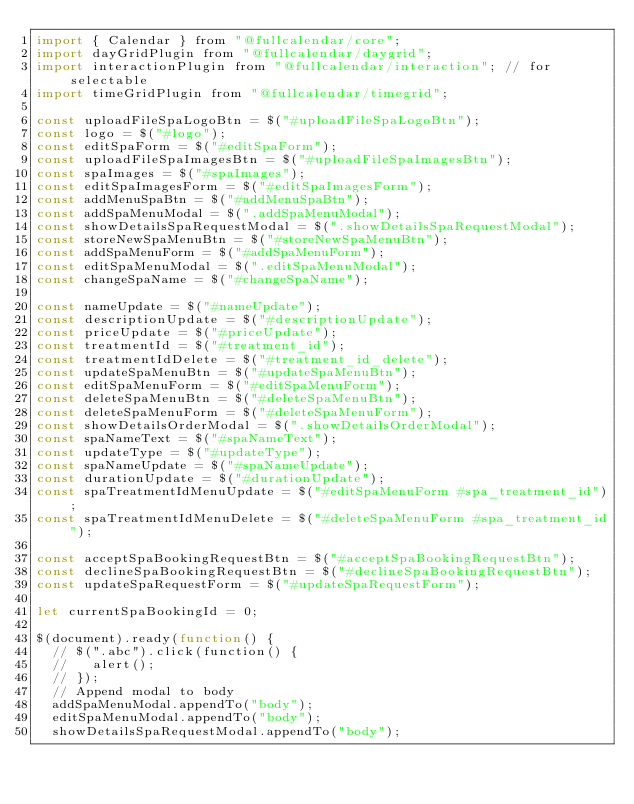Convert code to text. <code><loc_0><loc_0><loc_500><loc_500><_JavaScript_>import { Calendar } from "@fullcalendar/core";
import dayGridPlugin from "@fullcalendar/daygrid";
import interactionPlugin from "@fullcalendar/interaction"; // for selectable
import timeGridPlugin from "@fullcalendar/timegrid";

const uploadFileSpaLogoBtn = $("#uploadFileSpaLogoBtn");
const logo = $("#logo");
const editSpaForm = $("#editSpaForm");
const uploadFileSpaImagesBtn = $("#uploadFileSpaImagesBtn");
const spaImages = $("#spaImages");
const editSpaImagesForm = $("#editSpaImagesForm");
const addMenuSpaBtn = $("#addMenuSpaBtn");
const addSpaMenuModal = $(".addSpaMenuModal");
const showDetailsSpaRequestModal = $(".showDetailsSpaRequestModal");
const storeNewSpaMenuBtn = $("#storeNewSpaMenuBtn");
const addSpaMenuForm = $("#addSpaMenuForm");
const editSpaMenuModal = $(".editSpaMenuModal");
const changeSpaName = $("#changeSpaName");

const nameUpdate = $("#nameUpdate");
const descriptionUpdate = $("#descriptionUpdate");
const priceUpdate = $("#priceUpdate");
const treatmentId = $("#treatment_id");
const treatmentIdDelete = $("#treatment_id_delete");
const updateSpaMenuBtn = $("#updateSpaMenuBtn");
const editSpaMenuForm = $("#editSpaMenuForm");
const deleteSpaMenuBtn = $("#deleteSpaMenuBtn");
const deleteSpaMenuForm = $("#deleteSpaMenuForm");
const showDetailsOrderModal = $(".showDetailsOrderModal");
const spaNameText = $("#spaNameText");
const updateType = $("#updateType");
const spaNameUpdate = $("#spaNameUpdate");
const durationUpdate = $("#durationUpdate");
const spaTreatmentIdMenuUpdate = $("#editSpaMenuForm #spa_treatment_id");
const spaTreatmentIdMenuDelete = $("#deleteSpaMenuForm #spa_treatment_id");

const acceptSpaBookingRequestBtn = $("#acceptSpaBookingRequestBtn");
const declineSpaBookingRequestBtn = $("#declineSpaBookingRequestBtn");
const updateSpaRequestForm = $("#updateSpaRequestForm");

let currentSpaBookingId = 0;

$(document).ready(function() {
  // $(".abc").click(function() {
  //   alert();
  // });
  // Append modal to body
  addSpaMenuModal.appendTo("body");
  editSpaMenuModal.appendTo("body");
  showDetailsSpaRequestModal.appendTo("body");
</code> 